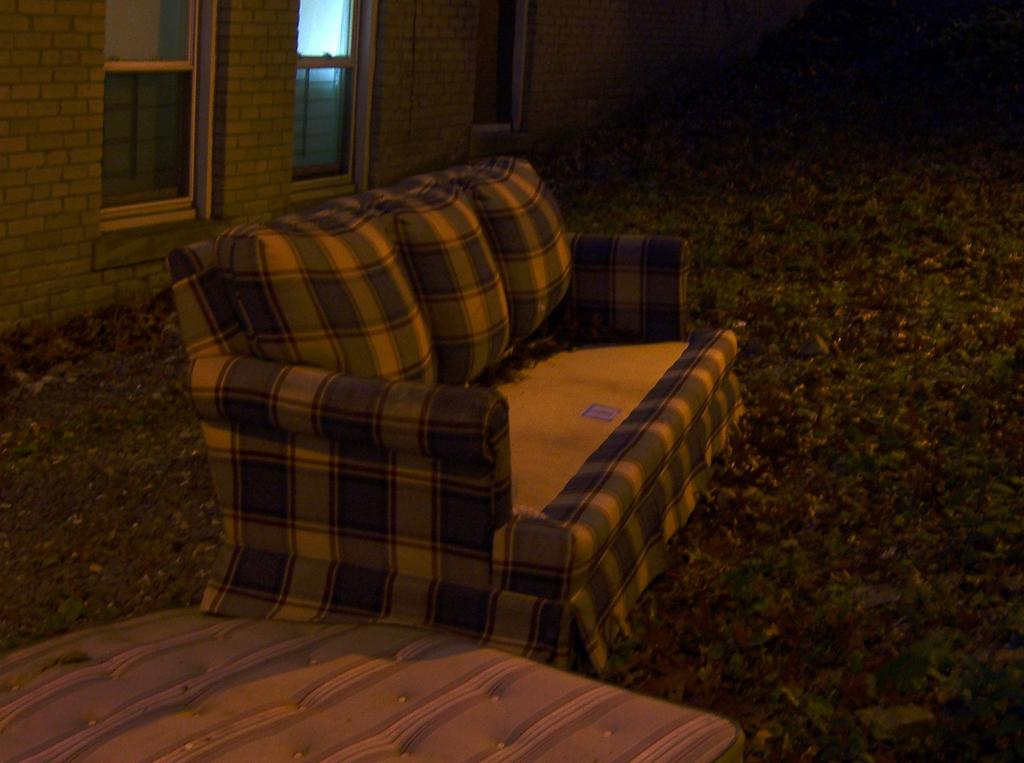What piece of furniture is located at the bottom of the image? There is a bed at the bottom of the image. What is the main piece of furniture in the center of the image? There is a couch in the center of the image. What can be seen on the left side of the image? There are windows and a wall on the left side of the image. What is the condition of the right side of the image? The right side of the image is not clear. How would you describe the lighting at the top of the image? The top of the image is dark. What type of beef is being weighed on the scale in the image? There is no beef or scale present in the image. What error can be seen in the image? There is no error visible in the image. 